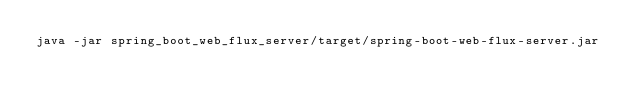<code> <loc_0><loc_0><loc_500><loc_500><_Bash_>java -jar spring_boot_web_flux_server/target/spring-boot-web-flux-server.jar</code> 